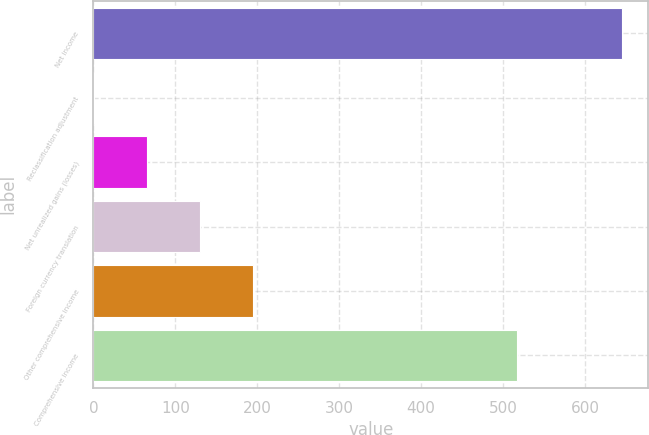<chart> <loc_0><loc_0><loc_500><loc_500><bar_chart><fcel>Net income<fcel>Reclassification adjustment<fcel>Net unrealized gains (losses)<fcel>Foreign currency translation<fcel>Other comprehensive income<fcel>Comprehensive income<nl><fcel>645<fcel>1<fcel>65.4<fcel>129.8<fcel>194.2<fcel>517<nl></chart> 